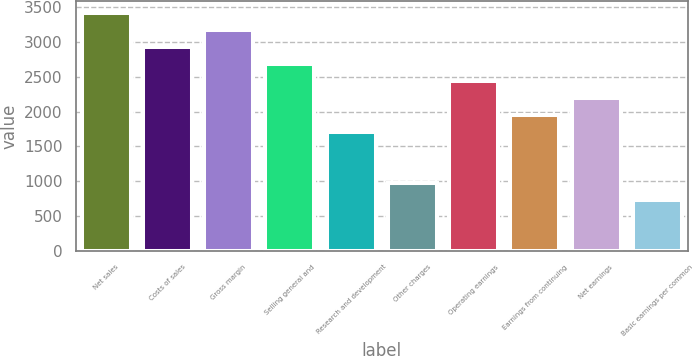Convert chart to OTSL. <chart><loc_0><loc_0><loc_500><loc_500><bar_chart><fcel>Net sales<fcel>Costs of sales<fcel>Gross margin<fcel>Selling general and<fcel>Research and development<fcel>Other charges<fcel>Operating earnings<fcel>Earnings from continuing<fcel>Net earnings<fcel>Basic earnings per common<nl><fcel>3417.24<fcel>2929.1<fcel>3173.17<fcel>2685.03<fcel>1708.75<fcel>976.54<fcel>2440.96<fcel>1952.82<fcel>2196.89<fcel>732.47<nl></chart> 